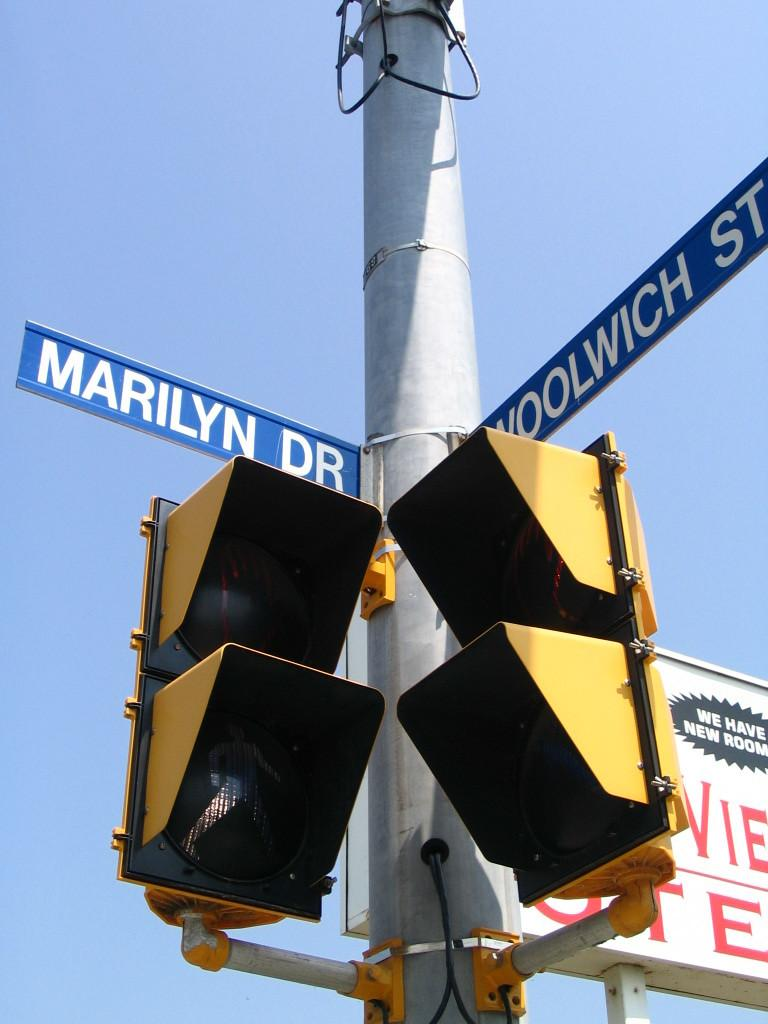<image>
Offer a succinct explanation of the picture presented. Two traffic lights on a pole at the corner of Marilyn Dr. and Woolwich St. 